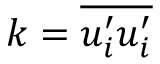<formula> <loc_0><loc_0><loc_500><loc_500>k = \overline { { u _ { i } ^ { \prime } u _ { i } ^ { \prime } } }</formula> 